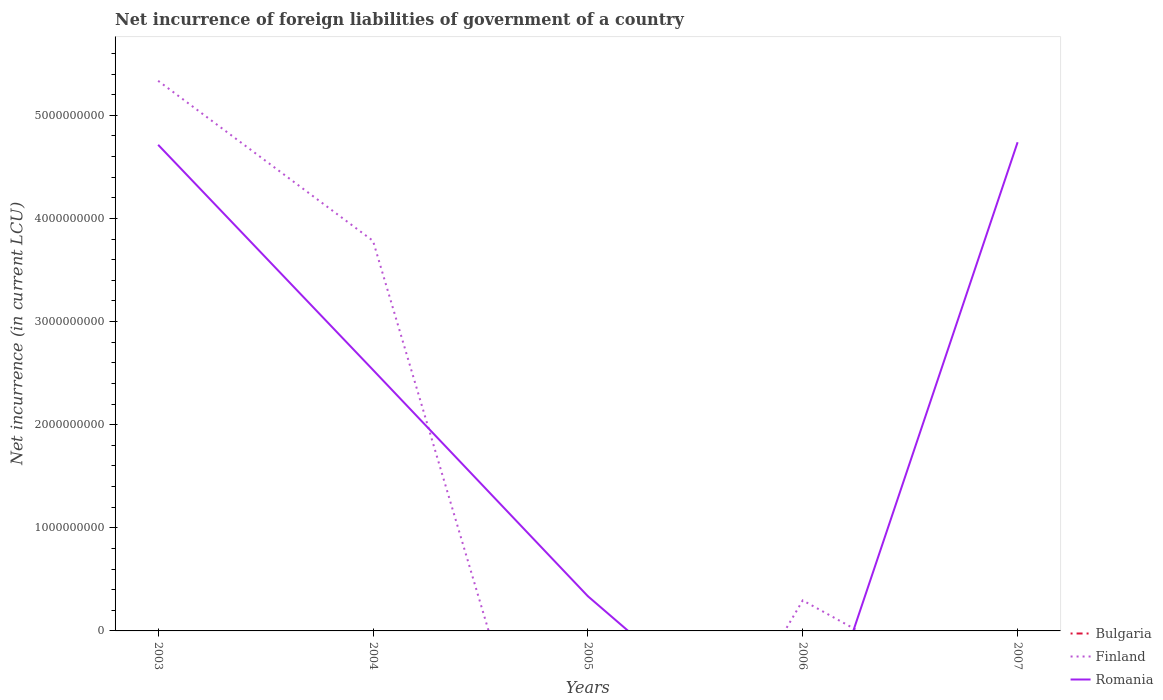Does the line corresponding to Bulgaria intersect with the line corresponding to Finland?
Provide a succinct answer. Yes. What is the total net incurrence of foreign liabilities in Finland in the graph?
Your response must be concise. 3.49e+09. What is the difference between the highest and the second highest net incurrence of foreign liabilities in Romania?
Your response must be concise. 4.74e+09. Is the net incurrence of foreign liabilities in Romania strictly greater than the net incurrence of foreign liabilities in Finland over the years?
Keep it short and to the point. No. What is the difference between two consecutive major ticks on the Y-axis?
Provide a short and direct response. 1.00e+09. Does the graph contain grids?
Provide a succinct answer. No. Where does the legend appear in the graph?
Provide a short and direct response. Bottom right. How many legend labels are there?
Keep it short and to the point. 3. What is the title of the graph?
Provide a succinct answer. Net incurrence of foreign liabilities of government of a country. What is the label or title of the Y-axis?
Your answer should be compact. Net incurrence (in current LCU). What is the Net incurrence (in current LCU) in Finland in 2003?
Your answer should be compact. 5.34e+09. What is the Net incurrence (in current LCU) of Romania in 2003?
Your answer should be very brief. 4.71e+09. What is the Net incurrence (in current LCU) in Finland in 2004?
Provide a short and direct response. 3.78e+09. What is the Net incurrence (in current LCU) of Romania in 2004?
Provide a succinct answer. 2.53e+09. What is the Net incurrence (in current LCU) of Romania in 2005?
Keep it short and to the point. 3.37e+08. What is the Net incurrence (in current LCU) of Finland in 2006?
Your answer should be compact. 2.96e+08. What is the Net incurrence (in current LCU) in Romania in 2006?
Offer a terse response. 0. What is the Net incurrence (in current LCU) in Bulgaria in 2007?
Keep it short and to the point. 0. What is the Net incurrence (in current LCU) in Romania in 2007?
Offer a very short reply. 4.74e+09. Across all years, what is the maximum Net incurrence (in current LCU) in Finland?
Your answer should be compact. 5.34e+09. Across all years, what is the maximum Net incurrence (in current LCU) in Romania?
Make the answer very short. 4.74e+09. Across all years, what is the minimum Net incurrence (in current LCU) of Finland?
Keep it short and to the point. 0. What is the total Net incurrence (in current LCU) in Bulgaria in the graph?
Offer a very short reply. 0. What is the total Net incurrence (in current LCU) in Finland in the graph?
Provide a short and direct response. 9.41e+09. What is the total Net incurrence (in current LCU) of Romania in the graph?
Keep it short and to the point. 1.23e+1. What is the difference between the Net incurrence (in current LCU) of Finland in 2003 and that in 2004?
Your response must be concise. 1.55e+09. What is the difference between the Net incurrence (in current LCU) of Romania in 2003 and that in 2004?
Ensure brevity in your answer.  2.18e+09. What is the difference between the Net incurrence (in current LCU) of Romania in 2003 and that in 2005?
Provide a succinct answer. 4.38e+09. What is the difference between the Net incurrence (in current LCU) in Finland in 2003 and that in 2006?
Offer a terse response. 5.04e+09. What is the difference between the Net incurrence (in current LCU) in Romania in 2003 and that in 2007?
Provide a short and direct response. -2.50e+07. What is the difference between the Net incurrence (in current LCU) of Romania in 2004 and that in 2005?
Offer a very short reply. 2.19e+09. What is the difference between the Net incurrence (in current LCU) of Finland in 2004 and that in 2006?
Offer a terse response. 3.49e+09. What is the difference between the Net incurrence (in current LCU) of Romania in 2004 and that in 2007?
Your response must be concise. -2.21e+09. What is the difference between the Net incurrence (in current LCU) of Romania in 2005 and that in 2007?
Offer a very short reply. -4.40e+09. What is the difference between the Net incurrence (in current LCU) in Finland in 2003 and the Net incurrence (in current LCU) in Romania in 2004?
Make the answer very short. 2.80e+09. What is the difference between the Net incurrence (in current LCU) in Finland in 2003 and the Net incurrence (in current LCU) in Romania in 2005?
Offer a very short reply. 5.00e+09. What is the difference between the Net incurrence (in current LCU) of Finland in 2003 and the Net incurrence (in current LCU) of Romania in 2007?
Your response must be concise. 5.96e+08. What is the difference between the Net incurrence (in current LCU) of Finland in 2004 and the Net incurrence (in current LCU) of Romania in 2005?
Keep it short and to the point. 3.45e+09. What is the difference between the Net incurrence (in current LCU) of Finland in 2004 and the Net incurrence (in current LCU) of Romania in 2007?
Keep it short and to the point. -9.56e+08. What is the difference between the Net incurrence (in current LCU) of Finland in 2006 and the Net incurrence (in current LCU) of Romania in 2007?
Keep it short and to the point. -4.44e+09. What is the average Net incurrence (in current LCU) of Finland per year?
Your answer should be compact. 1.88e+09. What is the average Net incurrence (in current LCU) in Romania per year?
Your response must be concise. 2.46e+09. In the year 2003, what is the difference between the Net incurrence (in current LCU) of Finland and Net incurrence (in current LCU) of Romania?
Offer a terse response. 6.21e+08. In the year 2004, what is the difference between the Net incurrence (in current LCU) of Finland and Net incurrence (in current LCU) of Romania?
Your answer should be compact. 1.25e+09. What is the ratio of the Net incurrence (in current LCU) of Finland in 2003 to that in 2004?
Your response must be concise. 1.41. What is the ratio of the Net incurrence (in current LCU) of Romania in 2003 to that in 2004?
Provide a succinct answer. 1.86. What is the ratio of the Net incurrence (in current LCU) of Romania in 2003 to that in 2005?
Your answer should be very brief. 14.01. What is the ratio of the Net incurrence (in current LCU) in Finland in 2003 to that in 2006?
Make the answer very short. 18.02. What is the ratio of the Net incurrence (in current LCU) of Romania in 2003 to that in 2007?
Your answer should be very brief. 0.99. What is the ratio of the Net incurrence (in current LCU) of Romania in 2004 to that in 2005?
Provide a succinct answer. 7.52. What is the ratio of the Net incurrence (in current LCU) in Finland in 2004 to that in 2006?
Your answer should be compact. 12.78. What is the ratio of the Net incurrence (in current LCU) of Romania in 2004 to that in 2007?
Offer a terse response. 0.53. What is the ratio of the Net incurrence (in current LCU) of Romania in 2005 to that in 2007?
Provide a succinct answer. 0.07. What is the difference between the highest and the second highest Net incurrence (in current LCU) in Finland?
Your answer should be very brief. 1.55e+09. What is the difference between the highest and the second highest Net incurrence (in current LCU) in Romania?
Keep it short and to the point. 2.50e+07. What is the difference between the highest and the lowest Net incurrence (in current LCU) of Finland?
Your response must be concise. 5.34e+09. What is the difference between the highest and the lowest Net incurrence (in current LCU) in Romania?
Provide a short and direct response. 4.74e+09. 